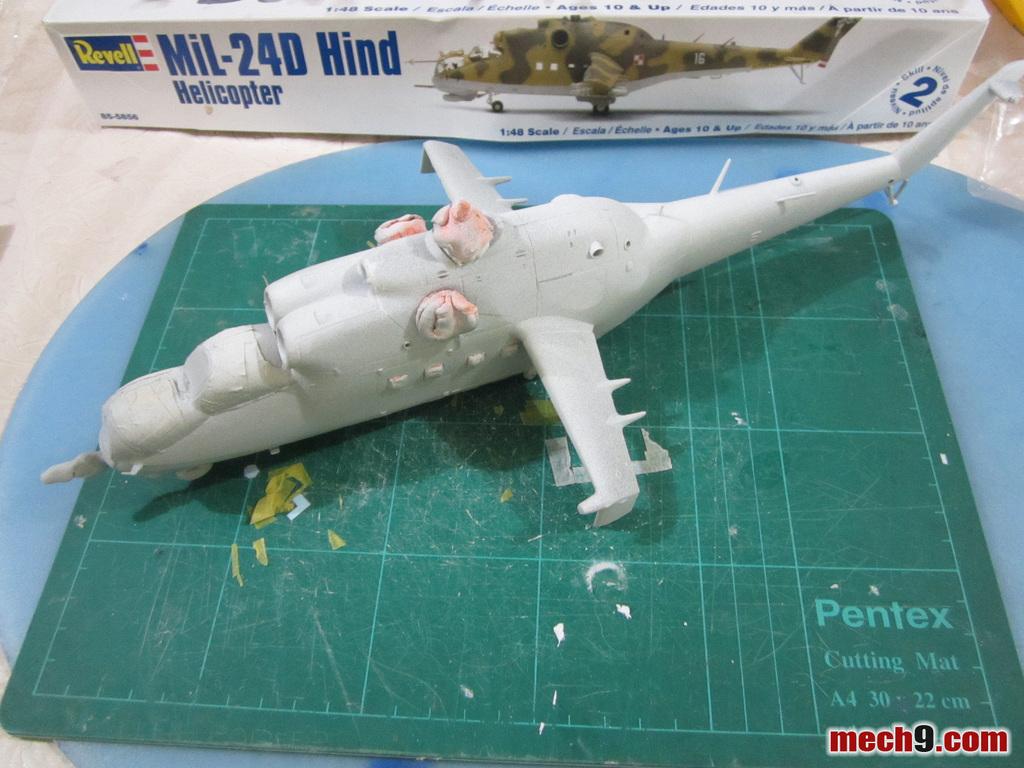What is the scale of this model?
Offer a terse response. 1:48. Is this a model kit of a helicopter or plane?
Your answer should be very brief. Helicopter. 